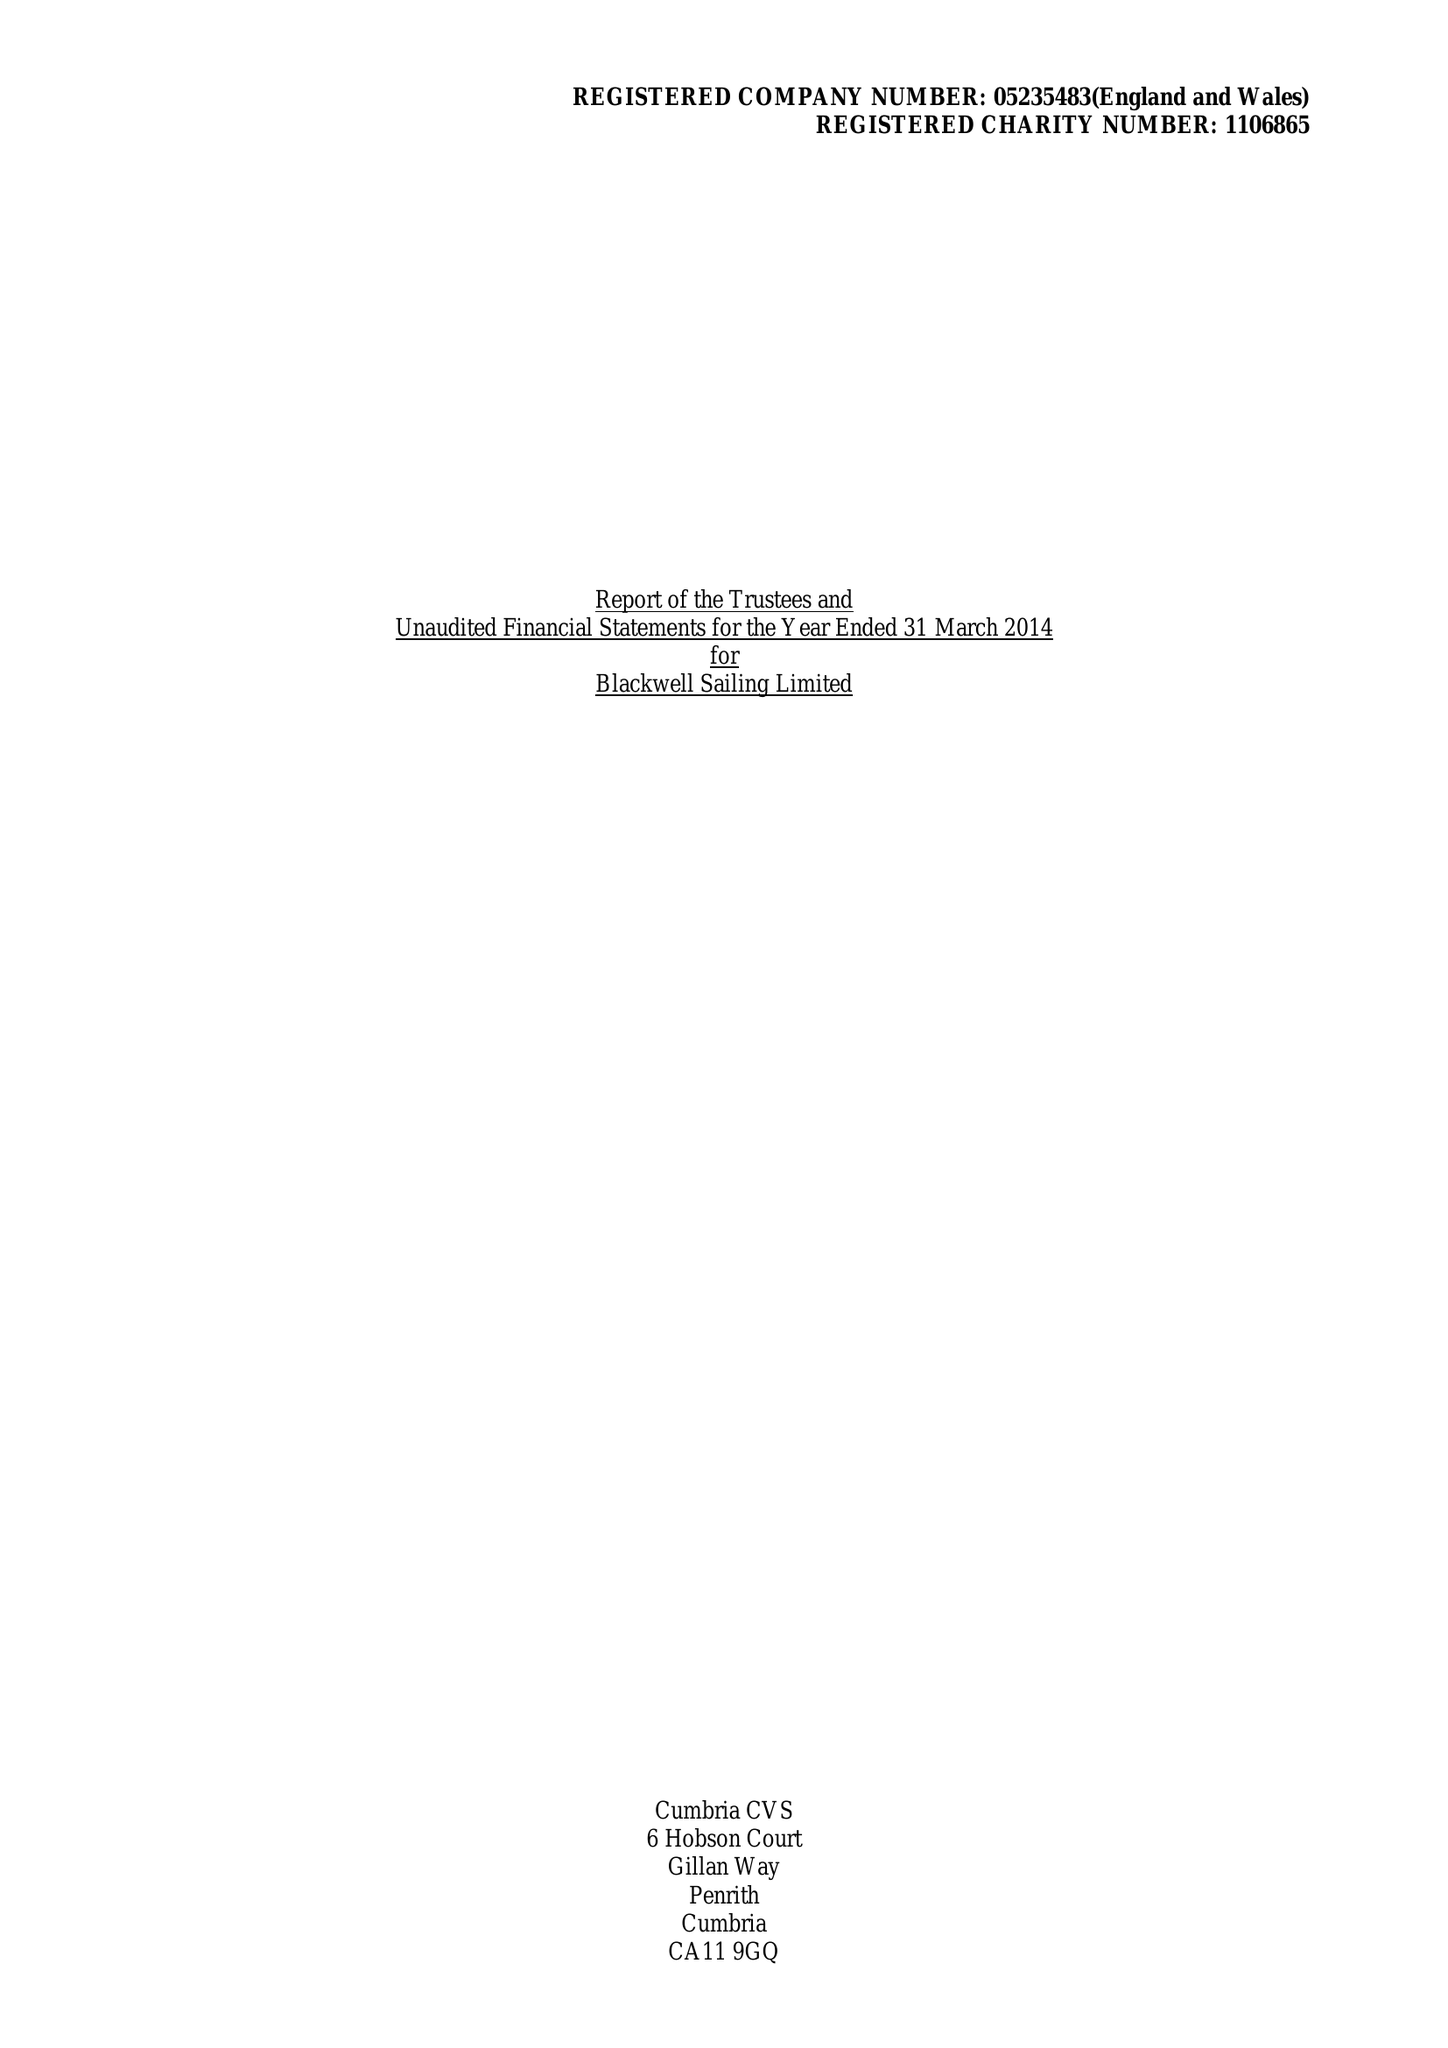What is the value for the address__street_line?
Answer the question using a single word or phrase. GLEBE ROAD 